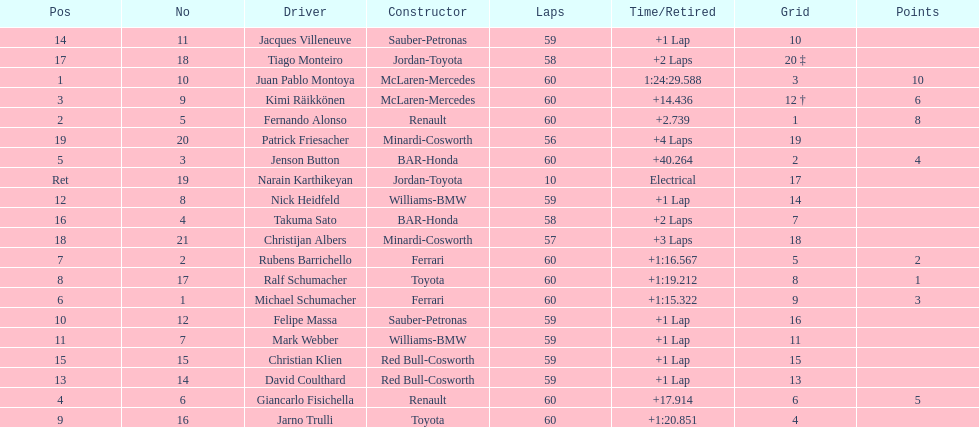After 8th position, how many points does a driver receive? 0. 